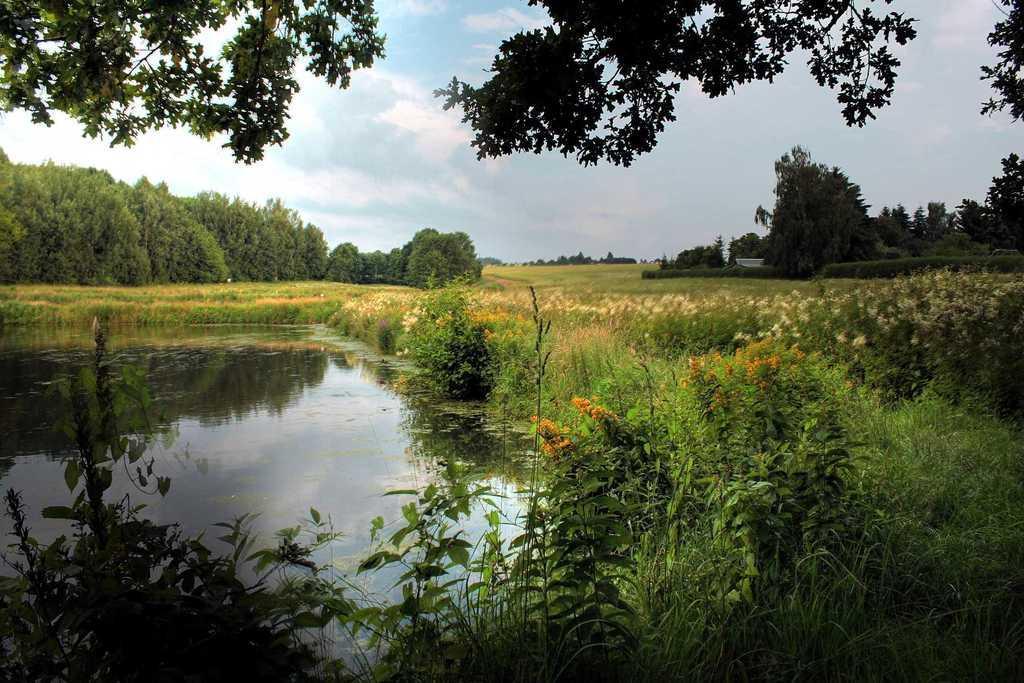Describe this image in one or two sentences. This image is taken outdoors. At the top of the image there is the sky with clouds and there are few trees. At the bottom of the image there is a ground with grass and a few plants on it. On the left side of the image there is a pond with water. In the background there are many trees and plants on the ground. On the right side of the image there are many plants. 